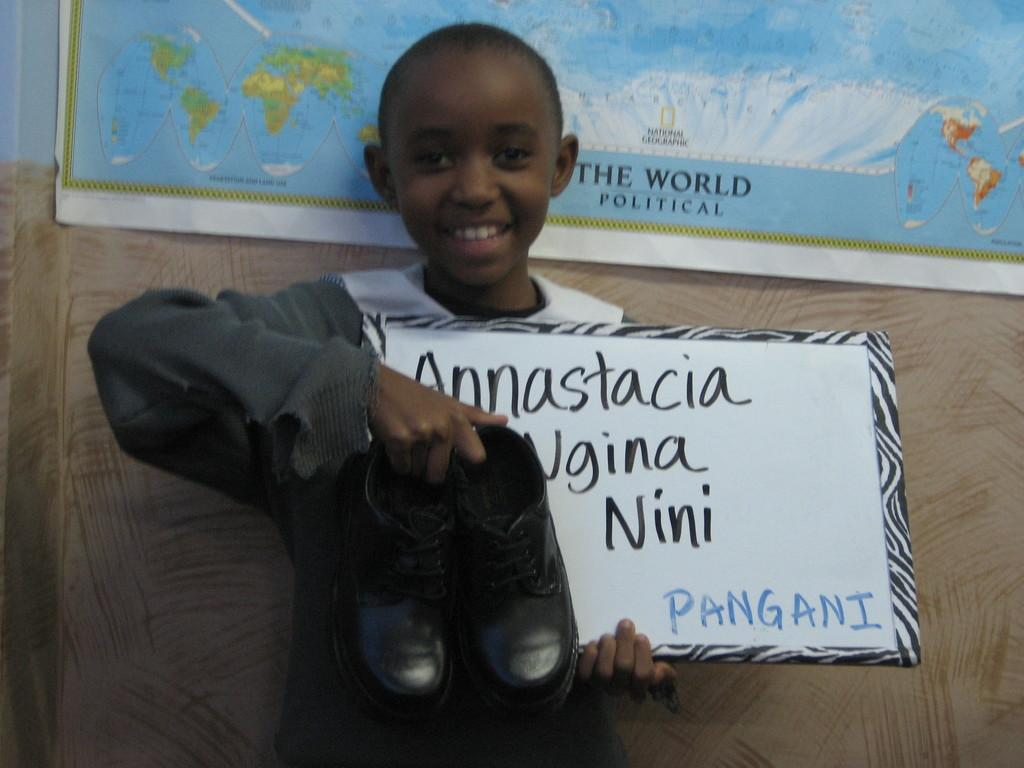What is on the wall in the image? There is a map banner with text on the wall. Who is present in the image? There is a boy standing near the wall. What is the boy holding in the image? The boy is holding black shoes. What else with text can be seen in the image? There is a board with text in the image. Is there a bear involved in a discussion with the boy in the image? No, there is no bear or discussion present in the image. Where is the girl in the image? There is no girl present in the image. 